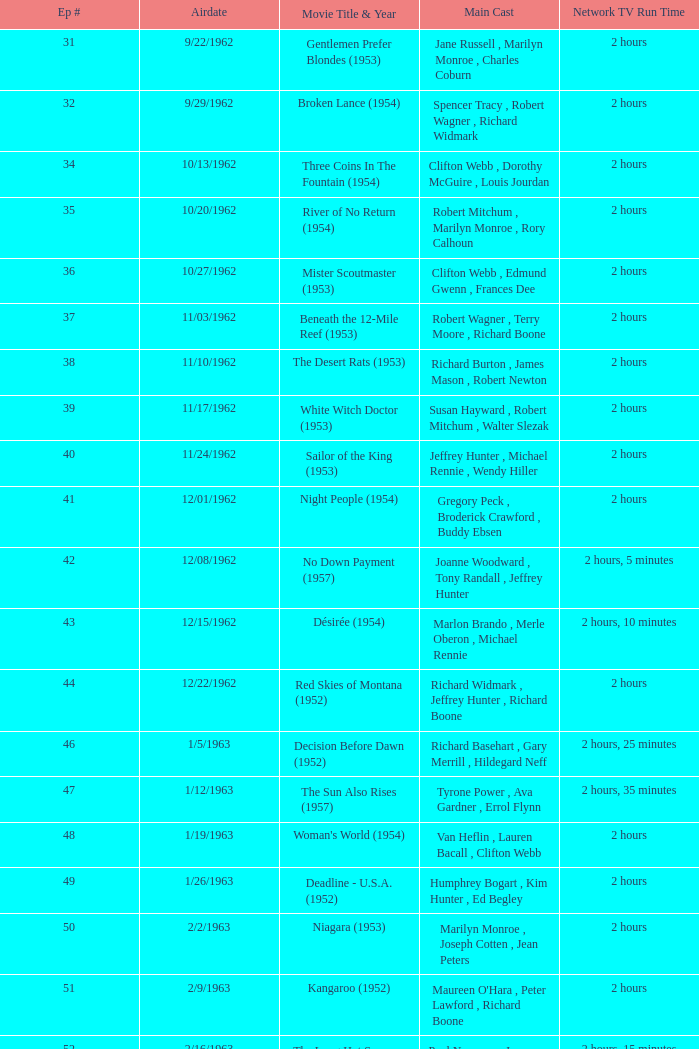How many runtimes does episode 53 have? 1.0. I'm looking to parse the entire table for insights. Could you assist me with that? {'header': ['Ep #', 'Airdate', 'Movie Title & Year', 'Main Cast', 'Network TV Run Time'], 'rows': [['31', '9/22/1962', 'Gentlemen Prefer Blondes (1953)', 'Jane Russell , Marilyn Monroe , Charles Coburn', '2 hours'], ['32', '9/29/1962', 'Broken Lance (1954)', 'Spencer Tracy , Robert Wagner , Richard Widmark', '2 hours'], ['34', '10/13/1962', 'Three Coins In The Fountain (1954)', 'Clifton Webb , Dorothy McGuire , Louis Jourdan', '2 hours'], ['35', '10/20/1962', 'River of No Return (1954)', 'Robert Mitchum , Marilyn Monroe , Rory Calhoun', '2 hours'], ['36', '10/27/1962', 'Mister Scoutmaster (1953)', 'Clifton Webb , Edmund Gwenn , Frances Dee', '2 hours'], ['37', '11/03/1962', 'Beneath the 12-Mile Reef (1953)', 'Robert Wagner , Terry Moore , Richard Boone', '2 hours'], ['38', '11/10/1962', 'The Desert Rats (1953)', 'Richard Burton , James Mason , Robert Newton', '2 hours'], ['39', '11/17/1962', 'White Witch Doctor (1953)', 'Susan Hayward , Robert Mitchum , Walter Slezak', '2 hours'], ['40', '11/24/1962', 'Sailor of the King (1953)', 'Jeffrey Hunter , Michael Rennie , Wendy Hiller', '2 hours'], ['41', '12/01/1962', 'Night People (1954)', 'Gregory Peck , Broderick Crawford , Buddy Ebsen', '2 hours'], ['42', '12/08/1962', 'No Down Payment (1957)', 'Joanne Woodward , Tony Randall , Jeffrey Hunter', '2 hours, 5 minutes'], ['43', '12/15/1962', 'Désirée (1954)', 'Marlon Brando , Merle Oberon , Michael Rennie', '2 hours, 10 minutes'], ['44', '12/22/1962', 'Red Skies of Montana (1952)', 'Richard Widmark , Jeffrey Hunter , Richard Boone', '2 hours'], ['46', '1/5/1963', 'Decision Before Dawn (1952)', 'Richard Basehart , Gary Merrill , Hildegard Neff', '2 hours, 25 minutes'], ['47', '1/12/1963', 'The Sun Also Rises (1957)', 'Tyrone Power , Ava Gardner , Errol Flynn', '2 hours, 35 minutes'], ['48', '1/19/1963', "Woman's World (1954)", 'Van Heflin , Lauren Bacall , Clifton Webb', '2 hours'], ['49', '1/26/1963', 'Deadline - U.S.A. (1952)', 'Humphrey Bogart , Kim Hunter , Ed Begley', '2 hours'], ['50', '2/2/1963', 'Niagara (1953)', 'Marilyn Monroe , Joseph Cotten , Jean Peters', '2 hours'], ['51', '2/9/1963', 'Kangaroo (1952)', "Maureen O'Hara , Peter Lawford , Richard Boone", '2 hours'], ['52', '2/16/1963', 'The Long Hot Summer (1958)', 'Paul Newman , Joanne Woodward , Orson Wells', '2 hours, 15 minutes'], ['53', '2/23/1963', "The President's Lady (1953)", 'Susan Hayward , Charlton Heston , John McIntire', '2 hours'], ['54', '3/2/1963', 'The Roots of Heaven (1958)', 'Errol Flynn , Juliette Greco , Eddie Albert', '2 hours, 25 minutes'], ['55', '3/9/1963', 'In Love and War (1958)', 'Robert Wagner , Hope Lange , Jeffrey Hunter', '2 hours, 10 minutes'], ['56', '3/16/1963', 'A Certain Smile (1958)', 'Rossano Brazzi , Joan Fontaine , Johnny Mathis', '2 hours, 5 minutes'], ['57', '3/23/1963', 'Fraulein (1958)', 'Dana Wynter , Mel Ferrer , Theodore Bikel', '2 hours'], ['59', '4/6/1963', 'Night and the City (1950)', 'Richard Widmark , Gene Tierney , Herbert Lom', '2 hours']]} 